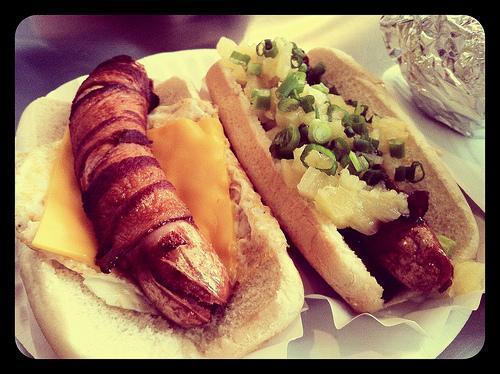How many sausages are in the picture?
Give a very brief answer. 2. 